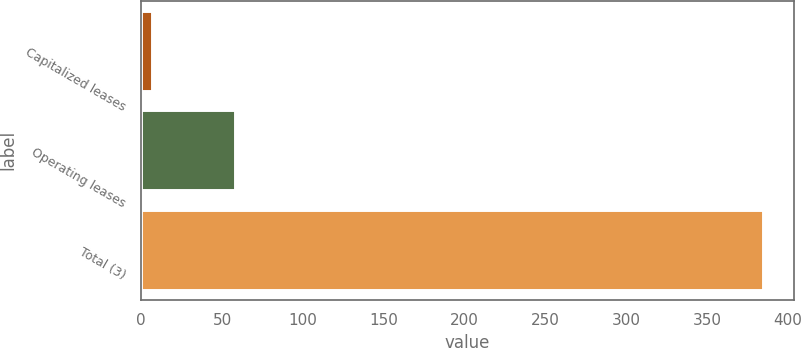Convert chart to OTSL. <chart><loc_0><loc_0><loc_500><loc_500><bar_chart><fcel>Capitalized leases<fcel>Operating leases<fcel>Total (3)<nl><fcel>6.5<fcel>57.8<fcel>384.2<nl></chart> 